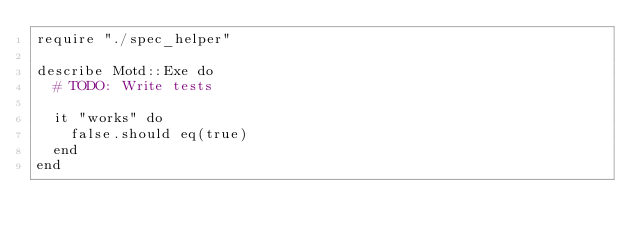<code> <loc_0><loc_0><loc_500><loc_500><_Crystal_>require "./spec_helper"

describe Motd::Exe do
  # TODO: Write tests

  it "works" do
    false.should eq(true)
  end
end
</code> 